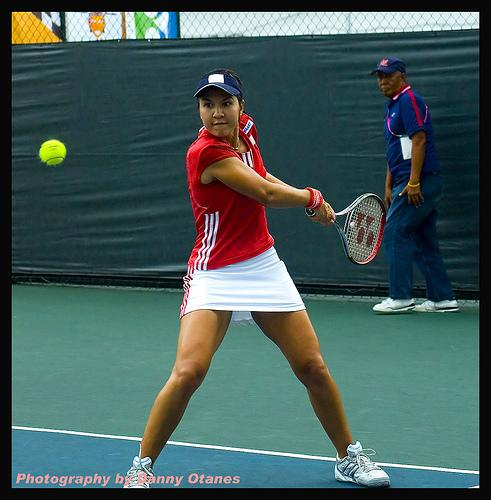The ball used in badminton is made up of what?

Choices:
A) wool
B) cotton
C) stone
D) wood wool 